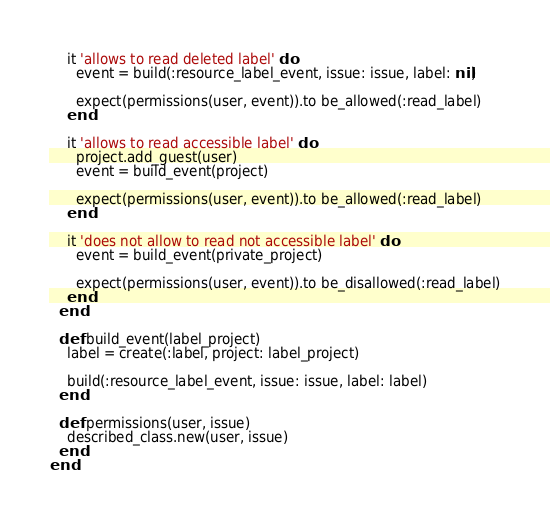Convert code to text. <code><loc_0><loc_0><loc_500><loc_500><_Ruby_>    it 'allows to read deleted label' do
      event = build(:resource_label_event, issue: issue, label: nil)

      expect(permissions(user, event)).to be_allowed(:read_label)
    end

    it 'allows to read accessible label' do
      project.add_guest(user)
      event = build_event(project)

      expect(permissions(user, event)).to be_allowed(:read_label)
    end

    it 'does not allow to read not accessible label' do
      event = build_event(private_project)

      expect(permissions(user, event)).to be_disallowed(:read_label)
    end
  end

  def build_event(label_project)
    label = create(:label, project: label_project)

    build(:resource_label_event, issue: issue, label: label)
  end

  def permissions(user, issue)
    described_class.new(user, issue)
  end
end
</code> 